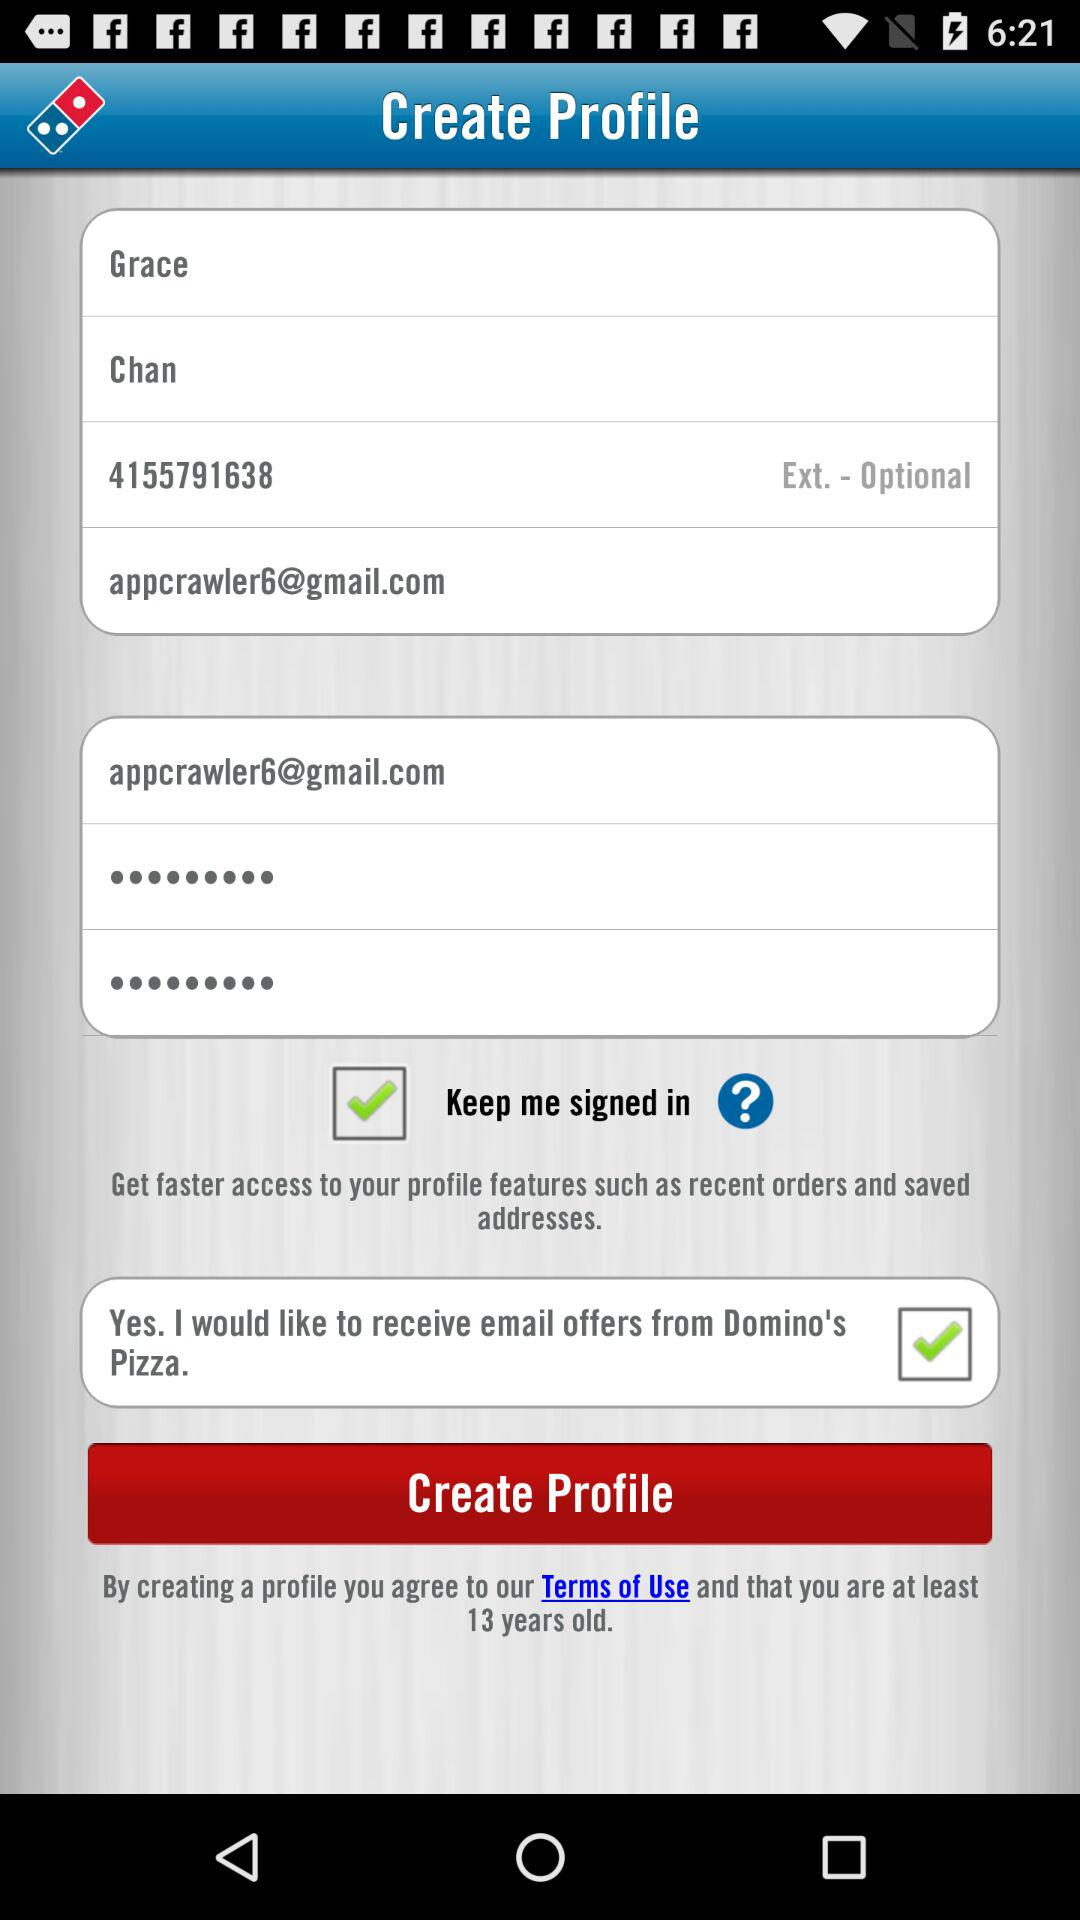What is the mentioned email address? The mentioned email address is appcrawler6@gmail.com. 